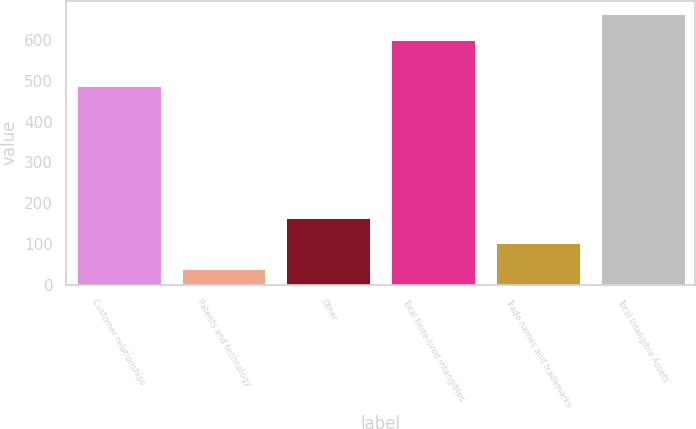Convert chart to OTSL. <chart><loc_0><loc_0><loc_500><loc_500><bar_chart><fcel>Customer relationships<fcel>Patents and technology<fcel>Other<fcel>Total finite-lived intangibles<fcel>Trade names and trademarks<fcel>Total Intangible Assets<nl><fcel>487.9<fcel>39<fcel>162.82<fcel>601.9<fcel>100.91<fcel>663.81<nl></chart> 